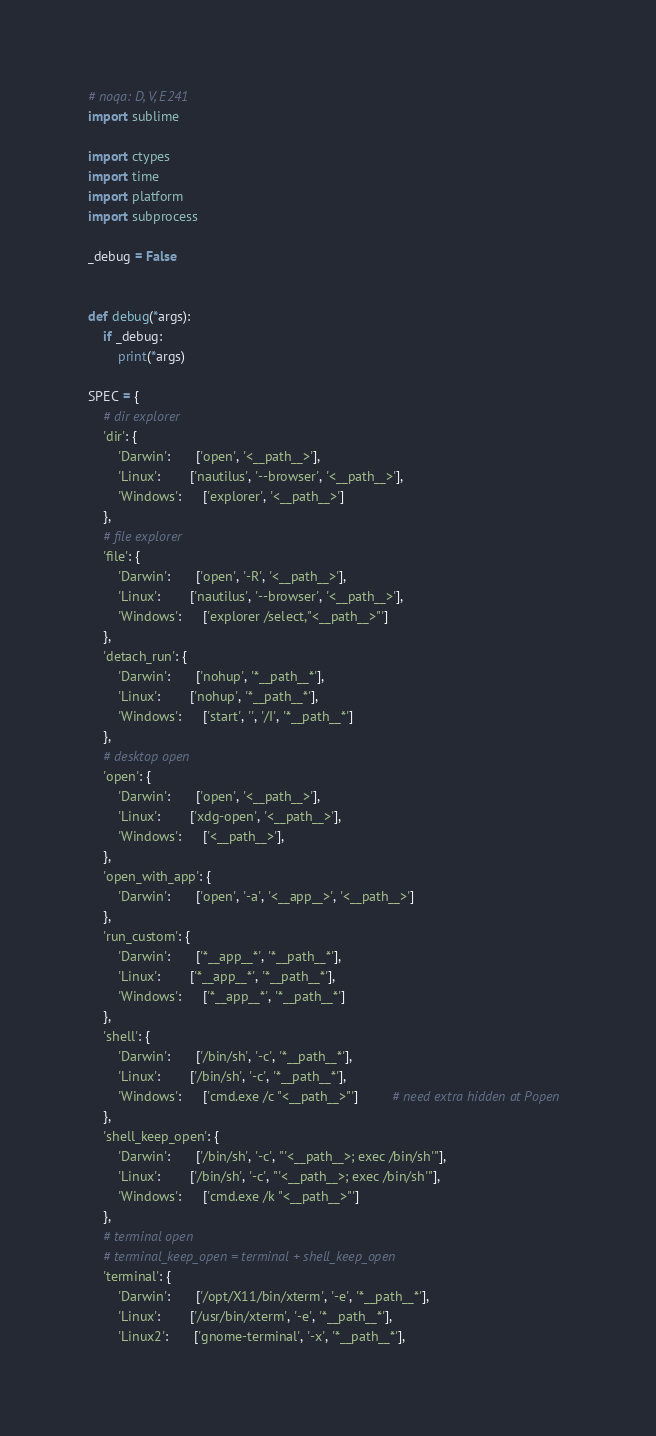<code> <loc_0><loc_0><loc_500><loc_500><_Python_># noqa: D, V, E241
import sublime

import ctypes
import time
import platform
import subprocess

_debug = False


def debug(*args):
    if _debug:
        print(*args)

SPEC = {
    # dir explorer
    'dir': {
        'Darwin':       ['open', '<__path__>'],
        'Linux':        ['nautilus', '--browser', '<__path__>'],
        'Windows':      ['explorer', '<__path__>']
    },
    # file explorer
    'file': {
        'Darwin':       ['open', '-R', '<__path__>'],
        'Linux':        ['nautilus', '--browser', '<__path__>'],
        'Windows':      ['explorer /select,"<__path__>"']
    },
    'detach_run': {
        'Darwin':       ['nohup', '*__path__*'],
        'Linux':        ['nohup', '*__path__*'],
        'Windows':      ['start', '', '/I', '*__path__*']
    },
    # desktop open
    'open': {
        'Darwin':       ['open', '<__path__>'],
        'Linux':        ['xdg-open', '<__path__>'],
        'Windows':      ['<__path__>'],
    },
    'open_with_app': {
        'Darwin':       ['open', '-a', '<__app__>', '<__path__>']
    },
    'run_custom': {
        'Darwin':       ['*__app__*', '*__path__*'],
        'Linux':        ['*__app__*', '*__path__*'],
        'Windows':      ['*__app__*', '*__path__*']
    },
    'shell': {
        'Darwin':       ['/bin/sh', '-c', '*__path__*'],
        'Linux':        ['/bin/sh', '-c', '*__path__*'],
        'Windows':      ['cmd.exe /c "<__path__>"']         # need extra hidden at Popen
    },
    'shell_keep_open': {
        'Darwin':       ['/bin/sh', '-c', "'<__path__>; exec /bin/sh'"],
        'Linux':        ['/bin/sh', '-c', "'<__path__>; exec /bin/sh'"],
        'Windows':      ['cmd.exe /k "<__path__>"']
    },
    # terminal open
    # terminal_keep_open = terminal + shell_keep_open
    'terminal': {
        'Darwin':       ['/opt/X11/bin/xterm', '-e', '*__path__*'],
        'Linux':        ['/usr/bin/xterm', '-e', '*__path__*'],
        'Linux2':       ['gnome-terminal', '-x', '*__path__*'],</code> 